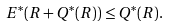<formula> <loc_0><loc_0><loc_500><loc_500>E ^ { * } ( R + Q ^ { * } ( R ) ) \leq Q ^ { * } ( R ) .</formula> 